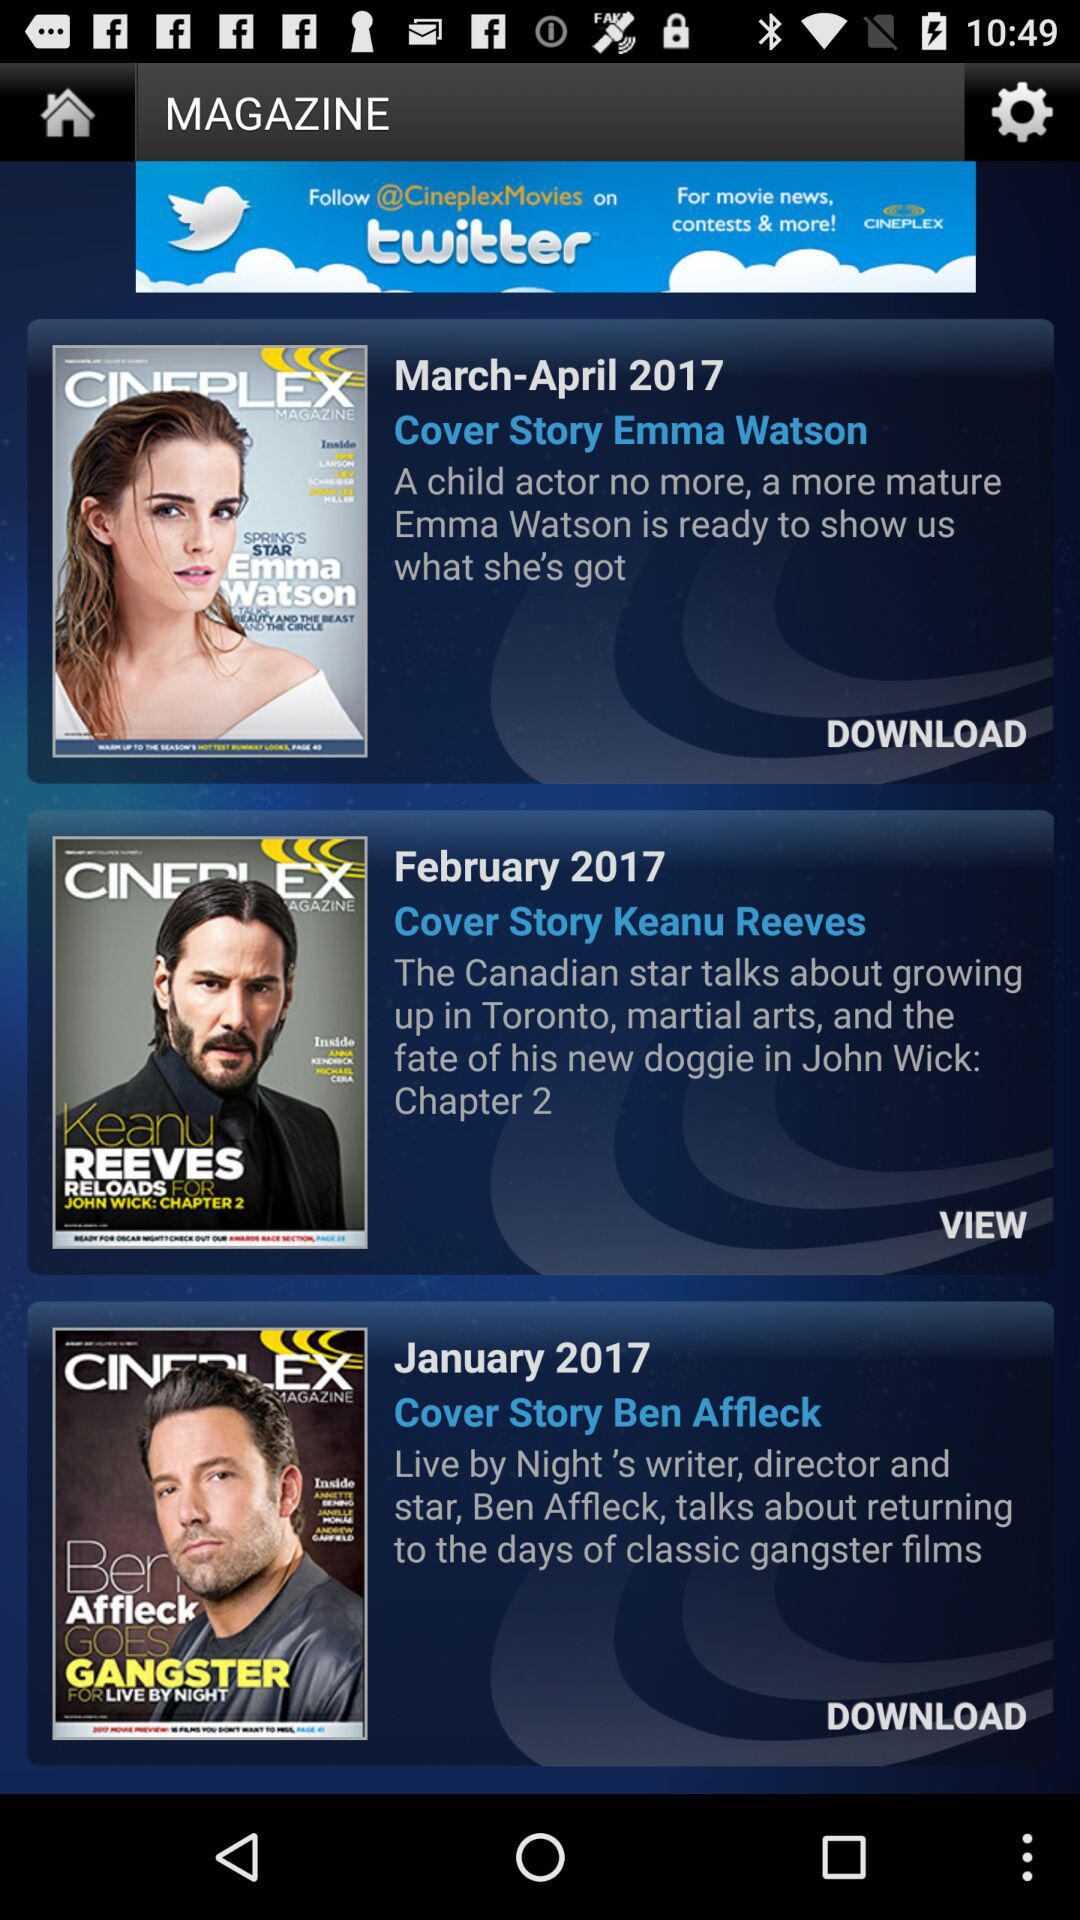What month and year are mentioned for "Cover Story Keanu Reeves"? The mentioned month is February and the mentioned year is 2017. 